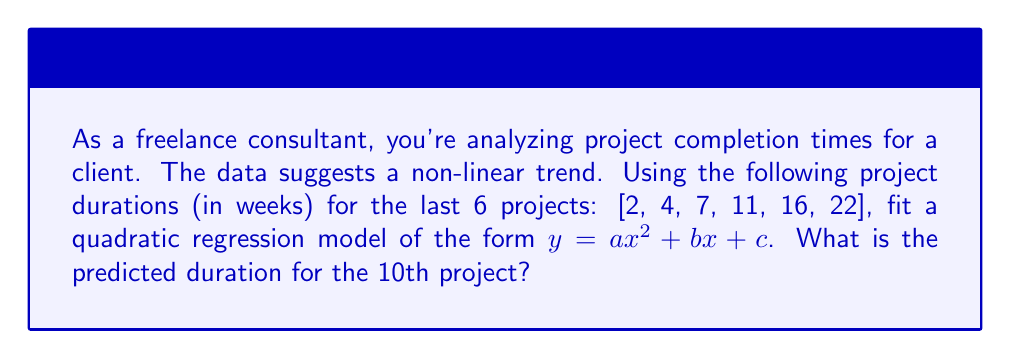Show me your answer to this math problem. To solve this problem, we'll follow these steps:

1) First, we need to set up our system of equations. For a quadratic regression, we use the form $y = ax^2 + bx + c$. Our data points are:

   $x: 1, 2, 3, 4, 5, 6$
   $y: 2, 4, 7, 11, 16, 22$

2) We need to solve for $a$, $b$, and $c$ using the normal equations:

   $$\begin{bmatrix}
   \sum x^4 & \sum x^3 & \sum x^2 \\
   \sum x^3 & \sum x^2 & \sum x \\
   \sum x^2 & \sum x & n
   \end{bmatrix}
   \begin{bmatrix}
   a \\
   b \\
   c
   \end{bmatrix} =
   \begin{bmatrix}
   \sum x^2y \\
   \sum xy \\
   \sum y
   \end{bmatrix}$$

3) Calculating the sums:

   $\sum x^4 = 979$
   $\sum x^3 = 336$
   $\sum x^2 = 91$
   $\sum x = 21$
   $n = 6$
   $\sum x^2y = 1660$
   $\sum xy = 305$
   $\sum y = 62$

4) Substituting into the matrix equation:

   $$\begin{bmatrix}
   979 & 336 & 91 \\
   336 & 91 & 21 \\
   91 & 21 & 6
   \end{bmatrix}
   \begin{bmatrix}
   a \\
   b \\
   c
   \end{bmatrix} =
   \begin{bmatrix}
   1660 \\
   305 \\
   62
   \end{bmatrix}$$

5) Solving this system (using a calculator or computer algebra system), we get:

   $a = 0.5$
   $b = 0.5$
   $c = 1$

6) Therefore, our quadratic regression model is:

   $y = 0.5x^2 + 0.5x + 1$

7) To predict the duration of the 10th project, we substitute $x = 10$:

   $y = 0.5(10)^2 + 0.5(10) + 1 = 50 + 5 + 1 = 56$

Thus, the predicted duration for the 10th project is 56 weeks.
Answer: 56 weeks 